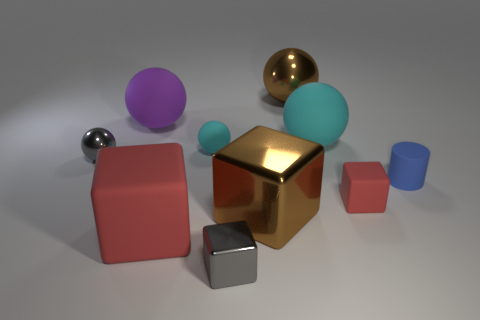Subtract all small red rubber blocks. How many blocks are left? 3 Subtract all cylinders. How many objects are left? 9 Subtract all green cylinders. How many brown spheres are left? 1 Subtract all brown cubes. How many cubes are left? 3 Subtract 1 spheres. How many spheres are left? 4 Subtract all tiny shiny blocks. Subtract all cyan spheres. How many objects are left? 7 Add 6 red blocks. How many red blocks are left? 8 Add 5 brown metallic cubes. How many brown metallic cubes exist? 6 Subtract 0 gray cylinders. How many objects are left? 10 Subtract all yellow spheres. Subtract all green cylinders. How many spheres are left? 5 